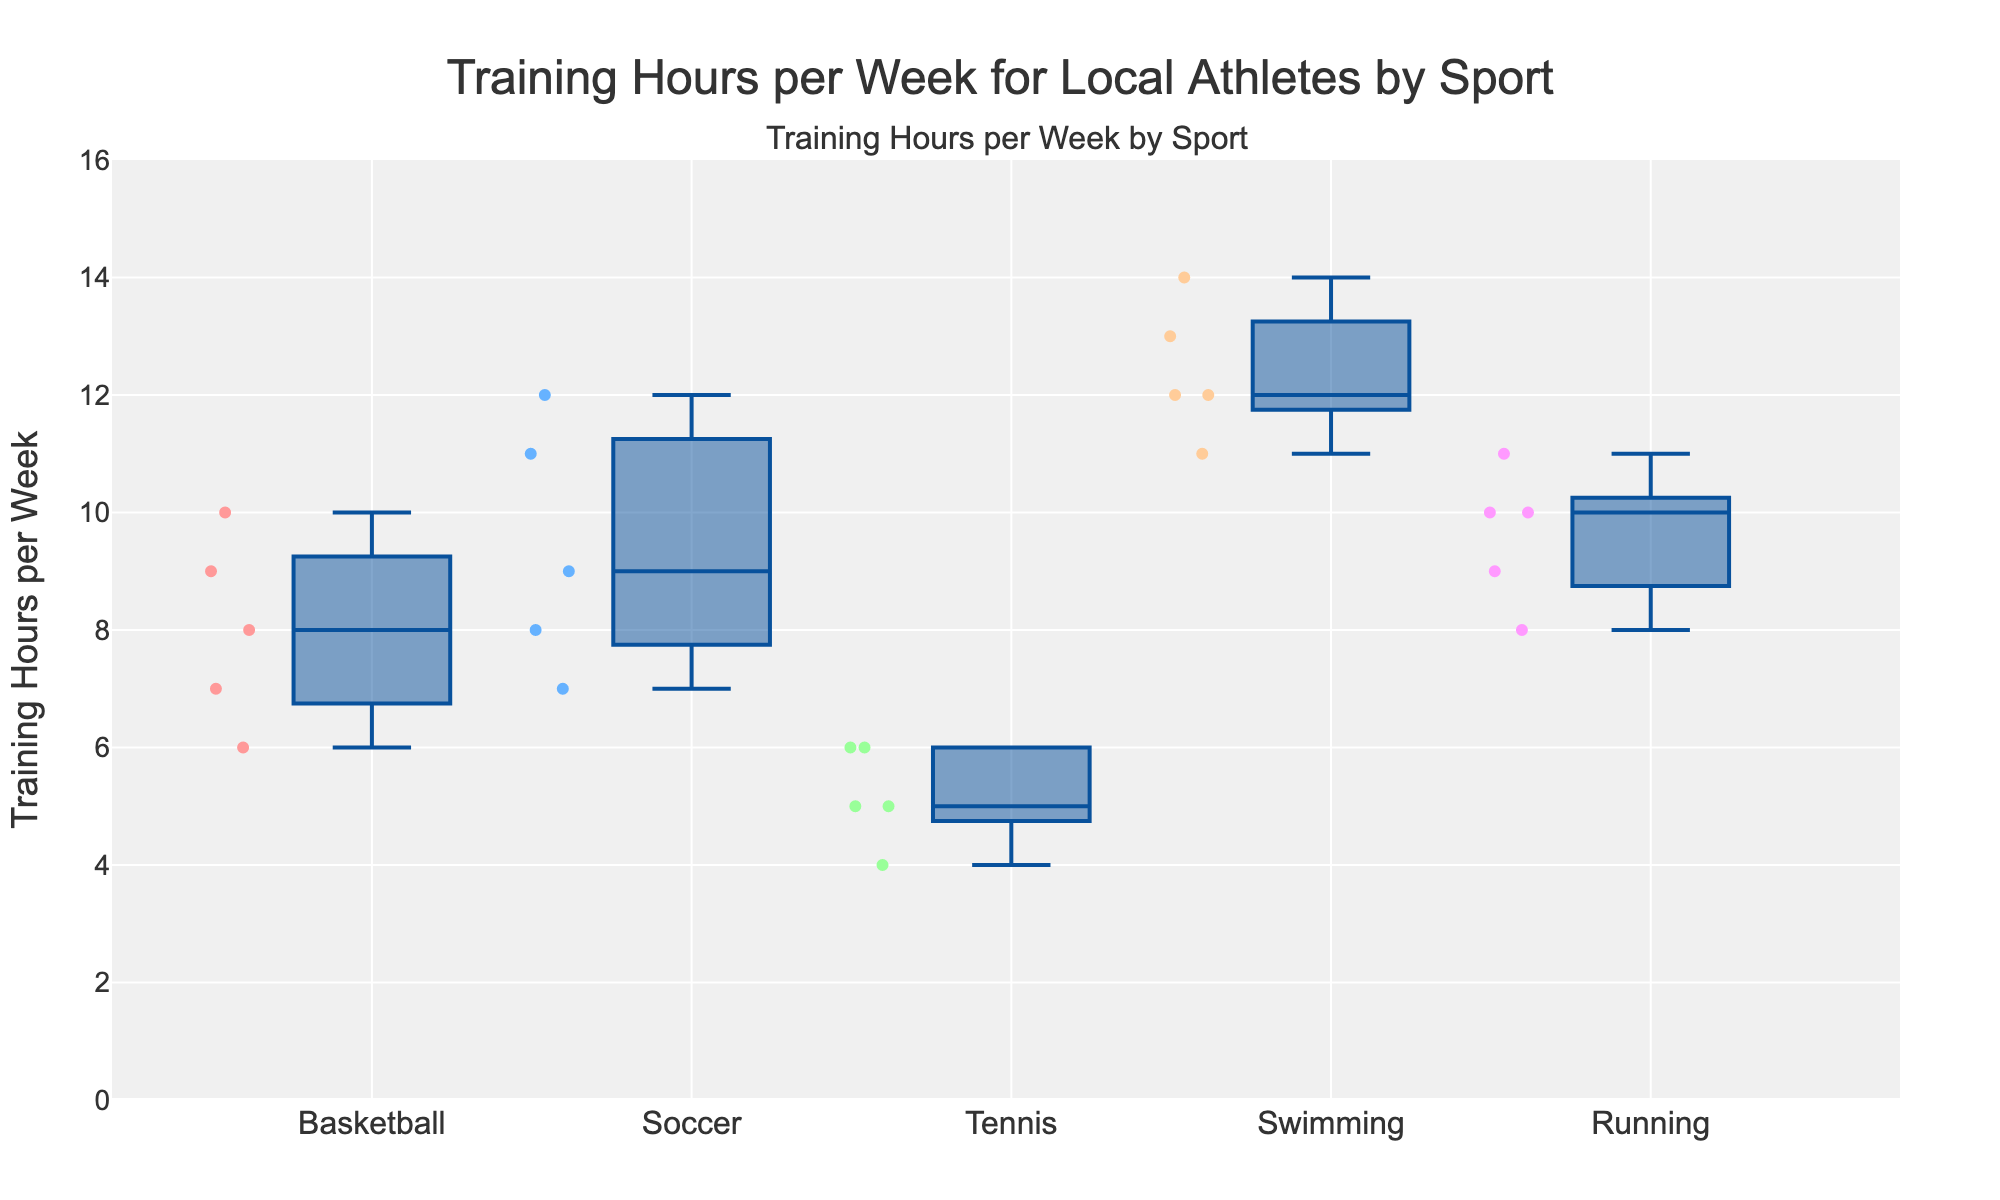what is the title of the figure? The title is usually found at the top of the figure and encapsulates its overall content. In this case, it reads: "Training Hours per Week for Local Athletes by Sport".
Answer: Training Hours per Week for Local Athletes by Sport what does the y-axis represent? On the left side of the figure, the y-axis is labeled as: "Training Hours per Week", indicating the range of hours athletes train per week.
Answer: Training Hours per Week which sport has the highest median training hours per week? Median value in a box plot is indicated by the line inside the box. Swimming box plot shows the highest median, between 12 and 13 hours.
Answer: Swimming how many sports are compared in the figure? Count the number of unique box plots in the figure. There are five different sports represented: Basketball, Soccer, Tennis, Swimming, and Running.
Answer: Five for tennis, what is the range of training hours per week? The range is the difference between the maximum and minimum values. In the Tennis box plot, the minimum is 4 and the maximum is 6. Therefore, the range is 6 - 4 = 2.
Answer: 2 which two sports have the closest median training hours per week? Comparing the medians of all sports, Basketball and Running have medians close to 9-10 hours, appearing very near to each other on the plot.
Answer: Basketball and Running are there any outliers? Outliers in a box plot are individual data points outside the whiskers. In this figure, all points lie within whiskers, implying no outliers.
Answer: No which sport has the widest interquartile range (IQR)? IQR is the range between the first and third quartile (Q1 and Q3). By observing the box heights, Swimming has the widest IQR (around 3 hours, from approximately 11 hours to 14 hours).
Answer: Swimming what sport has the most data points? Each dot within boxes represents individual data points. Swimming has five visible dots, making it the sport with most data points.
Answer: Swimming 